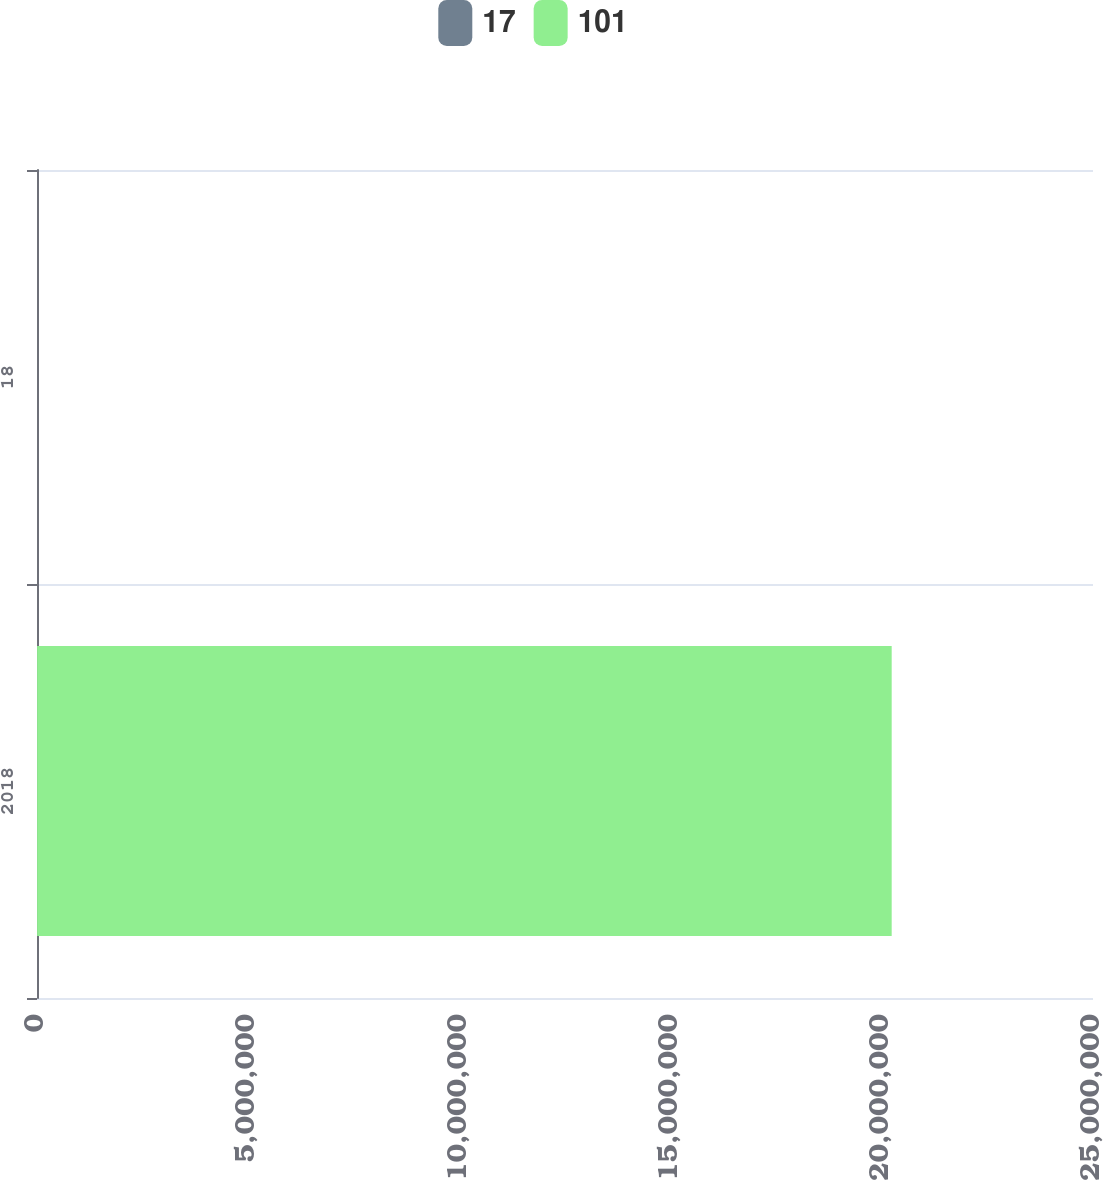Convert chart. <chart><loc_0><loc_0><loc_500><loc_500><stacked_bar_chart><ecel><fcel>2018<fcel>18<nl><fcel>17<fcel>2019<fcel>17<nl><fcel>101<fcel>2.0232e+07<fcel>101<nl></chart> 